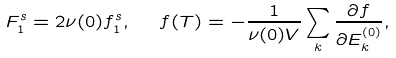Convert formula to latex. <formula><loc_0><loc_0><loc_500><loc_500>F _ { 1 } ^ { s } = 2 \nu ( 0 ) f _ { 1 } ^ { s } , \ \ f ( T ) = - \frac { 1 } { \nu ( 0 ) V } \sum _ { k } \frac { \partial f } { \partial E _ { k } ^ { ( 0 ) } } ,</formula> 